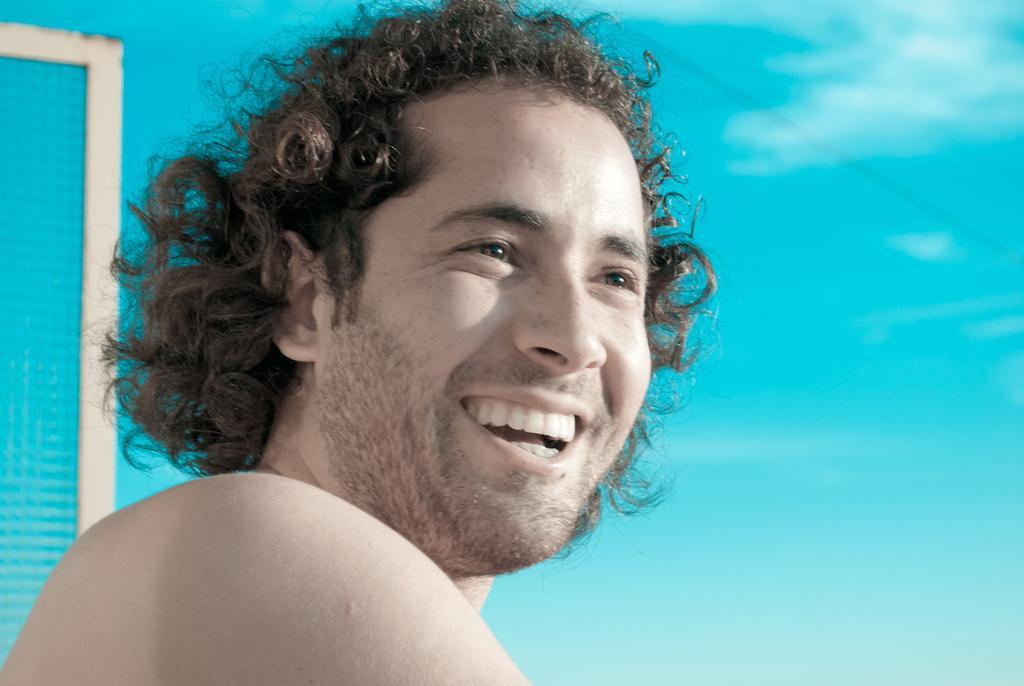Can you describe this image briefly? In the image there is a man, he is smiling and behind the man there is a sky. 